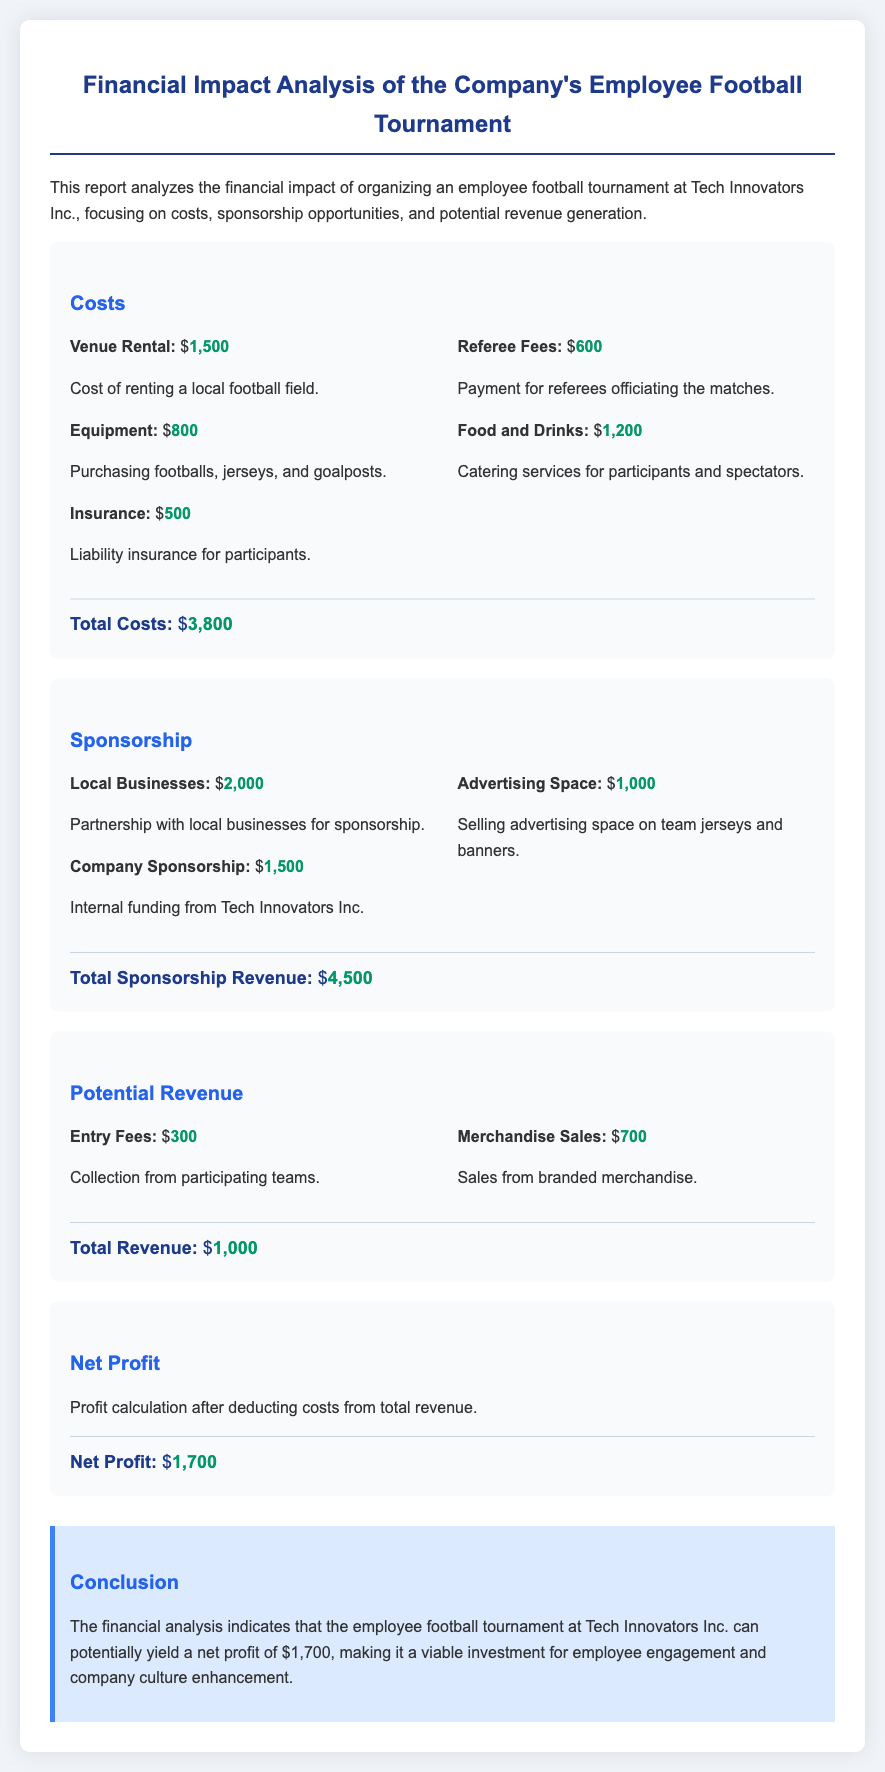what is the total cost of the tournament? The total cost is calculated by summing up all individual costs listed in the document, which are $1500, $800, $500, $600, and $1200.
Answer: $3800 what is the revenue from local businesses sponsorship? The document states that the revenue from local businesses sponsorship is $2000.
Answer: $2000 how much did the company spend on food and drinks? The document specifies that the company spent $1200 on food and drinks for participants and spectators.
Answer: $1200 what is the total sponsorship revenue? The total sponsorship revenue is the sum of the amounts from local businesses, company sponsorship, and advertising space, which are $2000, $1500, and $1000 respectively.
Answer: $4500 what is the net profit from the tournament? The net profit is calculated by subtracting total costs from total revenue, which results in $1000 (revenue) - $3800 (costs) = $1700.
Answer: $1700 what are the entry fees collected from participating teams? The entry fees collected from participating teams amount to $300 as stated in the document.
Answer: $300 what was the insurance cost for the tournament? The insurance cost, according to the document, is $500 for liability insurance.
Answer: $500 how much revenue was generated from merchandise sales? The revenue generated from merchandise sales is reported as $700.
Answer: $700 what is the total revenue from the tournament? The total revenue is calculated by adding entry fees and merchandise sales, which amounts to $300 and $700 respectively.
Answer: $1000 